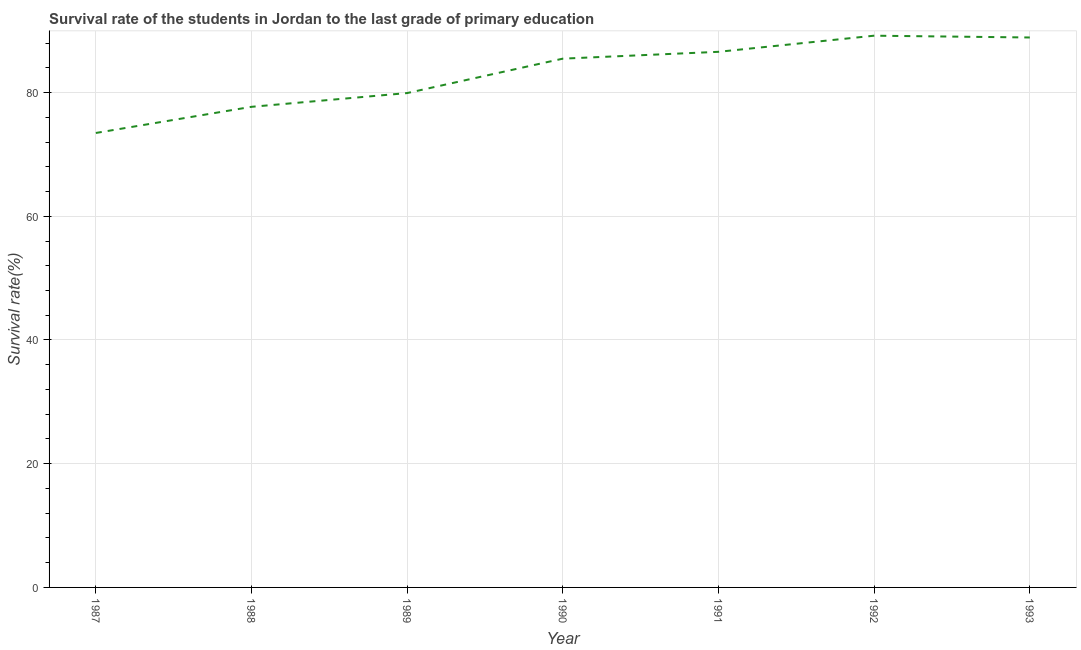What is the survival rate in primary education in 1992?
Offer a very short reply. 89.19. Across all years, what is the maximum survival rate in primary education?
Offer a very short reply. 89.19. Across all years, what is the minimum survival rate in primary education?
Provide a short and direct response. 73.46. In which year was the survival rate in primary education minimum?
Provide a succinct answer. 1987. What is the sum of the survival rate in primary education?
Your answer should be compact. 581.22. What is the difference between the survival rate in primary education in 1987 and 1992?
Give a very brief answer. -15.73. What is the average survival rate in primary education per year?
Provide a succinct answer. 83.03. What is the median survival rate in primary education?
Provide a short and direct response. 85.48. What is the ratio of the survival rate in primary education in 1987 to that in 1989?
Your response must be concise. 0.92. Is the survival rate in primary education in 1990 less than that in 1991?
Provide a succinct answer. Yes. Is the difference between the survival rate in primary education in 1990 and 1993 greater than the difference between any two years?
Offer a terse response. No. What is the difference between the highest and the second highest survival rate in primary education?
Your answer should be compact. 0.29. What is the difference between the highest and the lowest survival rate in primary education?
Ensure brevity in your answer.  15.73. In how many years, is the survival rate in primary education greater than the average survival rate in primary education taken over all years?
Give a very brief answer. 4. Does the survival rate in primary education monotonically increase over the years?
Your answer should be very brief. No. How many years are there in the graph?
Your answer should be compact. 7. What is the difference between two consecutive major ticks on the Y-axis?
Provide a short and direct response. 20. Are the values on the major ticks of Y-axis written in scientific E-notation?
Provide a succinct answer. No. Does the graph contain any zero values?
Ensure brevity in your answer.  No. Does the graph contain grids?
Provide a short and direct response. Yes. What is the title of the graph?
Make the answer very short. Survival rate of the students in Jordan to the last grade of primary education. What is the label or title of the Y-axis?
Your response must be concise. Survival rate(%). What is the Survival rate(%) of 1987?
Offer a terse response. 73.46. What is the Survival rate(%) of 1988?
Your response must be concise. 77.69. What is the Survival rate(%) in 1989?
Offer a terse response. 79.92. What is the Survival rate(%) in 1990?
Make the answer very short. 85.48. What is the Survival rate(%) in 1991?
Provide a succinct answer. 86.58. What is the Survival rate(%) in 1992?
Your answer should be compact. 89.19. What is the Survival rate(%) in 1993?
Give a very brief answer. 88.9. What is the difference between the Survival rate(%) in 1987 and 1988?
Offer a very short reply. -4.23. What is the difference between the Survival rate(%) in 1987 and 1989?
Offer a very short reply. -6.45. What is the difference between the Survival rate(%) in 1987 and 1990?
Offer a very short reply. -12.01. What is the difference between the Survival rate(%) in 1987 and 1991?
Your response must be concise. -13.12. What is the difference between the Survival rate(%) in 1987 and 1992?
Your answer should be very brief. -15.73. What is the difference between the Survival rate(%) in 1987 and 1993?
Your answer should be very brief. -15.44. What is the difference between the Survival rate(%) in 1988 and 1989?
Your answer should be compact. -2.22. What is the difference between the Survival rate(%) in 1988 and 1990?
Ensure brevity in your answer.  -7.79. What is the difference between the Survival rate(%) in 1988 and 1991?
Make the answer very short. -8.89. What is the difference between the Survival rate(%) in 1988 and 1992?
Ensure brevity in your answer.  -11.5. What is the difference between the Survival rate(%) in 1988 and 1993?
Ensure brevity in your answer.  -11.21. What is the difference between the Survival rate(%) in 1989 and 1990?
Offer a very short reply. -5.56. What is the difference between the Survival rate(%) in 1989 and 1991?
Ensure brevity in your answer.  -6.67. What is the difference between the Survival rate(%) in 1989 and 1992?
Make the answer very short. -9.27. What is the difference between the Survival rate(%) in 1989 and 1993?
Give a very brief answer. -8.98. What is the difference between the Survival rate(%) in 1990 and 1991?
Keep it short and to the point. -1.11. What is the difference between the Survival rate(%) in 1990 and 1992?
Provide a succinct answer. -3.71. What is the difference between the Survival rate(%) in 1990 and 1993?
Your answer should be compact. -3.42. What is the difference between the Survival rate(%) in 1991 and 1992?
Give a very brief answer. -2.61. What is the difference between the Survival rate(%) in 1991 and 1993?
Provide a short and direct response. -2.32. What is the difference between the Survival rate(%) in 1992 and 1993?
Keep it short and to the point. 0.29. What is the ratio of the Survival rate(%) in 1987 to that in 1988?
Offer a terse response. 0.95. What is the ratio of the Survival rate(%) in 1987 to that in 1989?
Offer a very short reply. 0.92. What is the ratio of the Survival rate(%) in 1987 to that in 1990?
Your response must be concise. 0.86. What is the ratio of the Survival rate(%) in 1987 to that in 1991?
Offer a terse response. 0.85. What is the ratio of the Survival rate(%) in 1987 to that in 1992?
Your answer should be very brief. 0.82. What is the ratio of the Survival rate(%) in 1987 to that in 1993?
Your response must be concise. 0.83. What is the ratio of the Survival rate(%) in 1988 to that in 1989?
Give a very brief answer. 0.97. What is the ratio of the Survival rate(%) in 1988 to that in 1990?
Ensure brevity in your answer.  0.91. What is the ratio of the Survival rate(%) in 1988 to that in 1991?
Keep it short and to the point. 0.9. What is the ratio of the Survival rate(%) in 1988 to that in 1992?
Offer a terse response. 0.87. What is the ratio of the Survival rate(%) in 1988 to that in 1993?
Provide a short and direct response. 0.87. What is the ratio of the Survival rate(%) in 1989 to that in 1990?
Keep it short and to the point. 0.94. What is the ratio of the Survival rate(%) in 1989 to that in 1991?
Provide a short and direct response. 0.92. What is the ratio of the Survival rate(%) in 1989 to that in 1992?
Keep it short and to the point. 0.9. What is the ratio of the Survival rate(%) in 1989 to that in 1993?
Offer a very short reply. 0.9. What is the ratio of the Survival rate(%) in 1990 to that in 1991?
Make the answer very short. 0.99. What is the ratio of the Survival rate(%) in 1990 to that in 1992?
Provide a succinct answer. 0.96. What is the ratio of the Survival rate(%) in 1991 to that in 1992?
Provide a short and direct response. 0.97. 